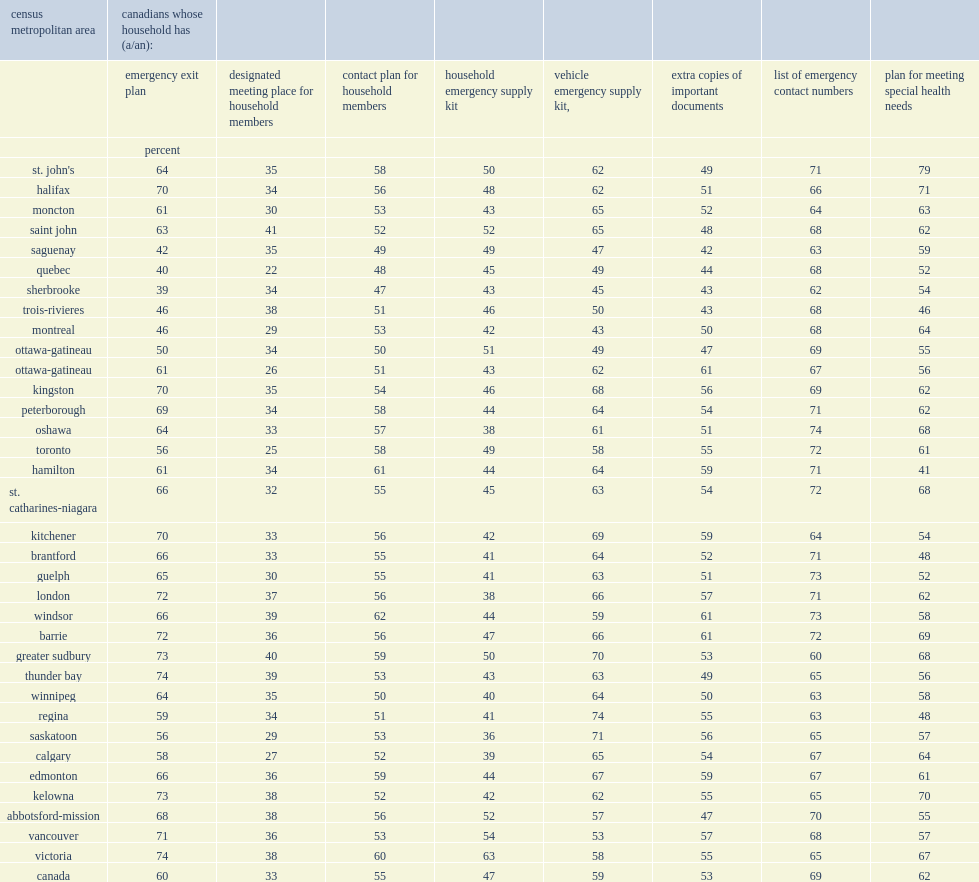For example, the presence of an emergency exit plan was most frequently reported by individuals in the respective british columbia and ontario cmas of victoria in 2014, what is the percentage of it? 74.0. For example, the presence of an emergency exit plan was most frequently reported by individuals in the respective british columbia and ontario cmas of thunder bay in 2014, what is the percentage of it? 74.0. What is the percentage of household emergency supply kits were especially common in the cmas of victoria in 2014? 63.0. What is the percentage of household emergency supply kits were especially common in the cmas of vancouver in 2014? 54.0. What is the percentage of household emergency supply kits were especially common in the cmas of abbotsford-mission in 2014? 52.0. Looking at the cma results also reveals that the proportion of individuals indicating that their household had a plan for meeting special health needs was noticeably higher in st. john's in 2014, what is the percentage? 79.0. Looking at the cma results also reveals that the proportion of individuals indicating that their household had a plan for meeting special health needs was noticeably higher in halifax in 2014, what is the percentage? 71.0. What is the percentage of regina recorded a comparatively high proportion of individuals with emergency supply kits for their vehicles in 2014? 74.0. 